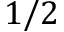Convert formula to latex. <formula><loc_0><loc_0><loc_500><loc_500>1 / 2</formula> 